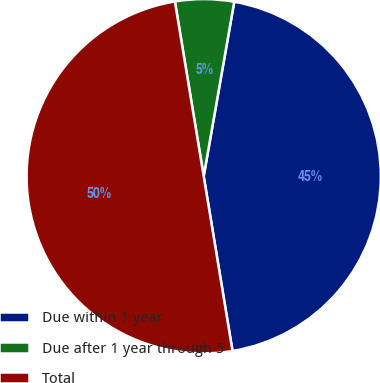Convert chart. <chart><loc_0><loc_0><loc_500><loc_500><pie_chart><fcel>Due within 1 year<fcel>Due after 1 year through 5<fcel>Total<nl><fcel>44.64%<fcel>5.36%<fcel>50.0%<nl></chart> 